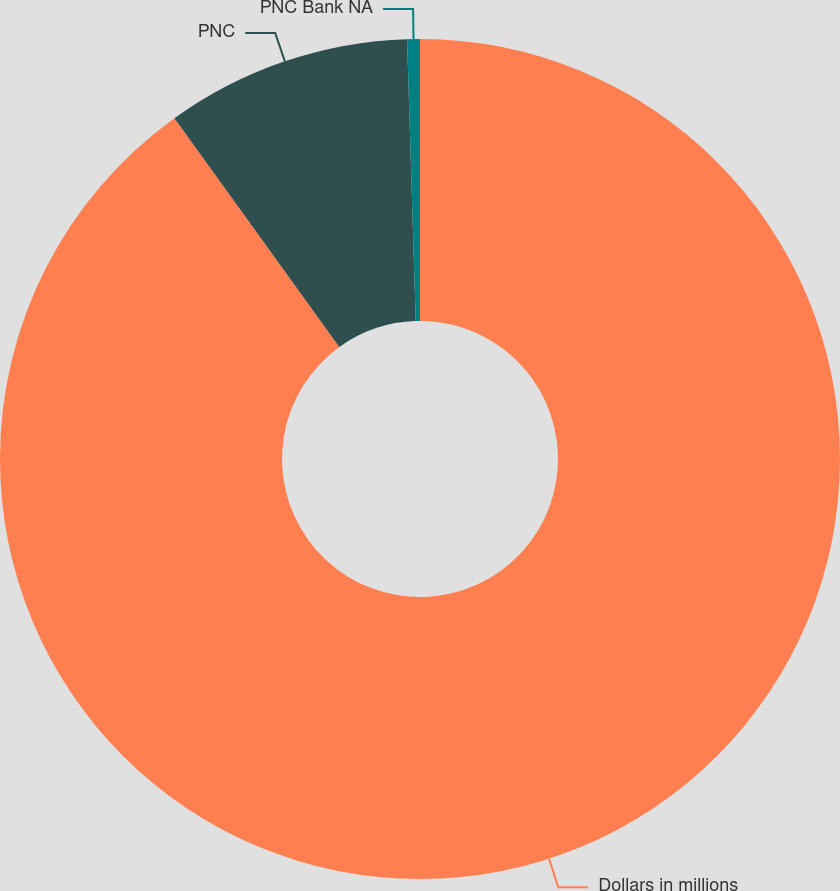Convert chart to OTSL. <chart><loc_0><loc_0><loc_500><loc_500><pie_chart><fcel>Dollars in millions<fcel>PNC<fcel>PNC Bank NA<nl><fcel>90.07%<fcel>9.45%<fcel>0.49%<nl></chart> 